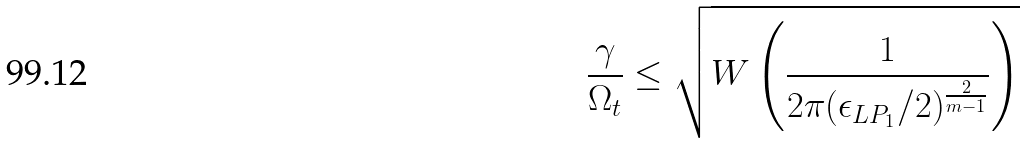Convert formula to latex. <formula><loc_0><loc_0><loc_500><loc_500>\frac { \gamma } { \Omega _ { t } } \leq \sqrt { W \left ( \frac { 1 } { 2 \pi ( \epsilon _ { L P _ { 1 } } / 2 ) ^ { \frac { 2 } { m - 1 } } } \right ) }</formula> 